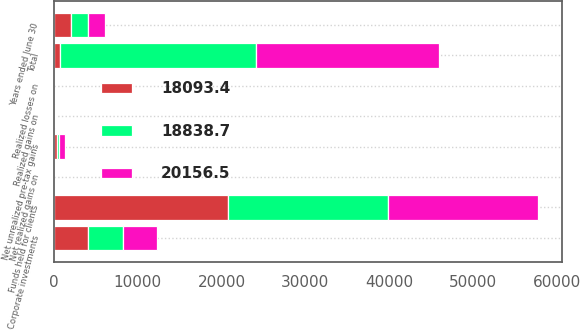Convert chart to OTSL. <chart><loc_0><loc_0><loc_500><loc_500><stacked_bar_chart><ecel><fcel>Years ended June 30<fcel>Corporate investments<fcel>Funds held for clients<fcel>Total<fcel>Realized gains on<fcel>Realized losses on<fcel>Net realized gains on<fcel>Net unrealized pre-tax gains<nl><fcel>18093.4<fcel>2014<fcel>4072.4<fcel>20726.5<fcel>710.5<fcel>20.4<fcel>3.9<fcel>16.5<fcel>324.4<nl><fcel>18838.7<fcel>2013<fcel>4200.3<fcel>19156.3<fcel>23356.6<fcel>32.1<fcel>3.5<fcel>28.6<fcel>287.4<nl><fcel>20156.5<fcel>2012<fcel>4024.6<fcel>17898.2<fcel>21922.8<fcel>32.1<fcel>7.7<fcel>24.4<fcel>710.5<nl></chart> 